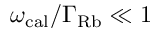<formula> <loc_0><loc_0><loc_500><loc_500>\omega _ { c a l } / \Gamma _ { R b } \ll 1</formula> 